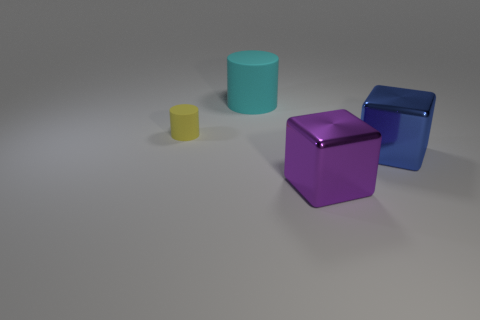Add 1 big yellow matte spheres. How many objects exist? 5 Add 1 big green shiny blocks. How many big green shiny blocks exist? 1 Subtract 0 green blocks. How many objects are left? 4 Subtract all small brown balls. Subtract all blue blocks. How many objects are left? 3 Add 4 big blue blocks. How many big blue blocks are left? 5 